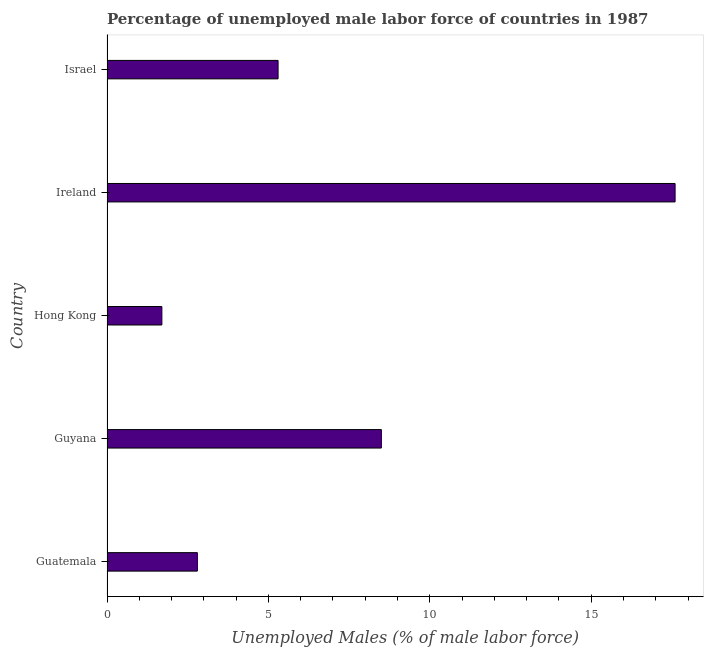Does the graph contain grids?
Your answer should be very brief. No. What is the title of the graph?
Keep it short and to the point. Percentage of unemployed male labor force of countries in 1987. What is the label or title of the X-axis?
Ensure brevity in your answer.  Unemployed Males (% of male labor force). What is the total unemployed male labour force in Guatemala?
Offer a very short reply. 2.8. Across all countries, what is the maximum total unemployed male labour force?
Your answer should be very brief. 17.6. Across all countries, what is the minimum total unemployed male labour force?
Provide a short and direct response. 1.7. In which country was the total unemployed male labour force maximum?
Your response must be concise. Ireland. In which country was the total unemployed male labour force minimum?
Provide a succinct answer. Hong Kong. What is the sum of the total unemployed male labour force?
Ensure brevity in your answer.  35.9. What is the difference between the total unemployed male labour force in Guatemala and Ireland?
Provide a short and direct response. -14.8. What is the average total unemployed male labour force per country?
Give a very brief answer. 7.18. What is the median total unemployed male labour force?
Give a very brief answer. 5.3. In how many countries, is the total unemployed male labour force greater than 16 %?
Offer a terse response. 1. What is the ratio of the total unemployed male labour force in Guyana to that in Hong Kong?
Provide a succinct answer. 5. Is the difference between the total unemployed male labour force in Guatemala and Guyana greater than the difference between any two countries?
Provide a succinct answer. No. Is the sum of the total unemployed male labour force in Guatemala and Ireland greater than the maximum total unemployed male labour force across all countries?
Keep it short and to the point. Yes. How many countries are there in the graph?
Provide a succinct answer. 5. What is the difference between two consecutive major ticks on the X-axis?
Provide a short and direct response. 5. Are the values on the major ticks of X-axis written in scientific E-notation?
Give a very brief answer. No. What is the Unemployed Males (% of male labor force) in Guatemala?
Keep it short and to the point. 2.8. What is the Unemployed Males (% of male labor force) in Hong Kong?
Keep it short and to the point. 1.7. What is the Unemployed Males (% of male labor force) in Ireland?
Offer a terse response. 17.6. What is the Unemployed Males (% of male labor force) of Israel?
Provide a succinct answer. 5.3. What is the difference between the Unemployed Males (% of male labor force) in Guatemala and Guyana?
Keep it short and to the point. -5.7. What is the difference between the Unemployed Males (% of male labor force) in Guatemala and Hong Kong?
Offer a terse response. 1.1. What is the difference between the Unemployed Males (% of male labor force) in Guatemala and Ireland?
Ensure brevity in your answer.  -14.8. What is the difference between the Unemployed Males (% of male labor force) in Guyana and Hong Kong?
Your answer should be very brief. 6.8. What is the difference between the Unemployed Males (% of male labor force) in Guyana and Ireland?
Your response must be concise. -9.1. What is the difference between the Unemployed Males (% of male labor force) in Guyana and Israel?
Your answer should be very brief. 3.2. What is the difference between the Unemployed Males (% of male labor force) in Hong Kong and Ireland?
Your response must be concise. -15.9. What is the ratio of the Unemployed Males (% of male labor force) in Guatemala to that in Guyana?
Your response must be concise. 0.33. What is the ratio of the Unemployed Males (% of male labor force) in Guatemala to that in Hong Kong?
Keep it short and to the point. 1.65. What is the ratio of the Unemployed Males (% of male labor force) in Guatemala to that in Ireland?
Offer a very short reply. 0.16. What is the ratio of the Unemployed Males (% of male labor force) in Guatemala to that in Israel?
Your answer should be compact. 0.53. What is the ratio of the Unemployed Males (% of male labor force) in Guyana to that in Hong Kong?
Your response must be concise. 5. What is the ratio of the Unemployed Males (% of male labor force) in Guyana to that in Ireland?
Offer a very short reply. 0.48. What is the ratio of the Unemployed Males (% of male labor force) in Guyana to that in Israel?
Provide a short and direct response. 1.6. What is the ratio of the Unemployed Males (% of male labor force) in Hong Kong to that in Ireland?
Provide a short and direct response. 0.1. What is the ratio of the Unemployed Males (% of male labor force) in Hong Kong to that in Israel?
Your answer should be very brief. 0.32. What is the ratio of the Unemployed Males (% of male labor force) in Ireland to that in Israel?
Give a very brief answer. 3.32. 